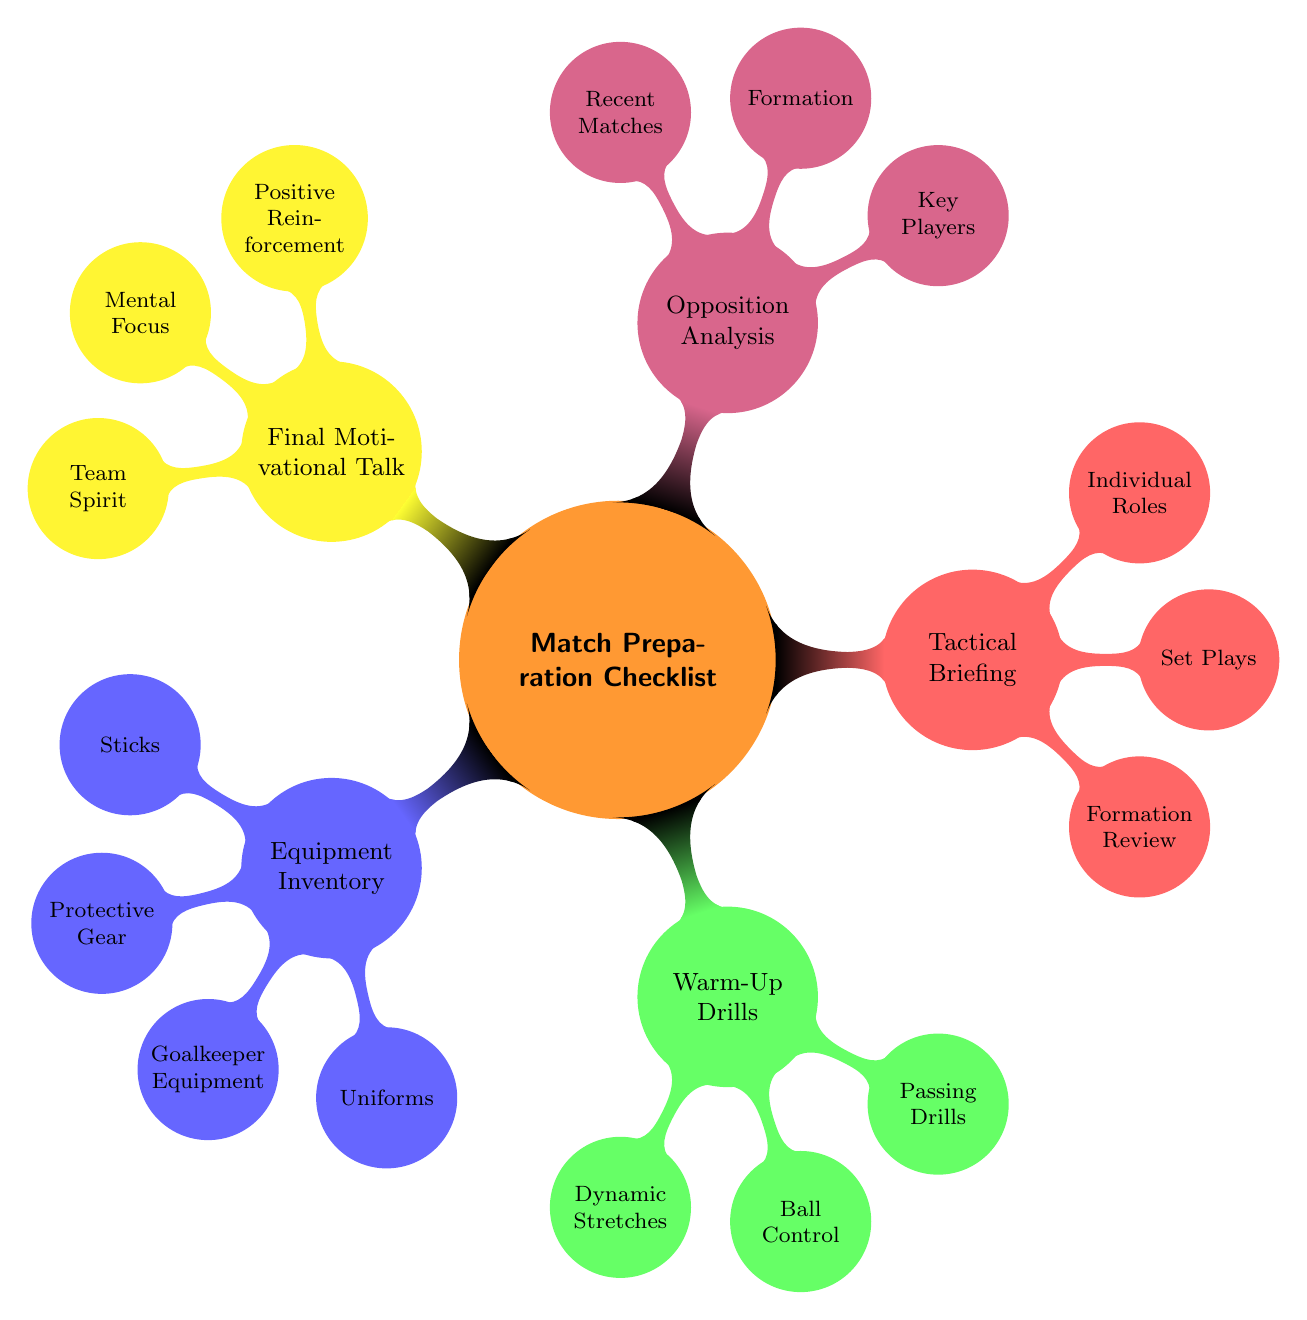What are the main categories in the match preparation checklist? The main categories are listed as child nodes under the "Match Preparation Checklist" node. They include Equipment Inventory, Warm-Up Drills, Tactical Briefing, Opposition Analysis, and Final Motivational Talk.
Answer: Equipment Inventory, Warm-Up Drills, Tactical Briefing, Opposition Analysis, Final Motivational Talk How many items are listed under Tactical Briefing? To find the number of items, we count the child nodes under the "Tactical Briefing" node, which includes Formation Review, Set Plays, Individual Roles, and Opposition Weaknesses. There are four items total.
Answer: 4 Which node is connected to "Key Players"? The "Key Players" node is a child of the "Opposition Analysis" node. This can be determined by looking at the hierarchy in the mind map structure.
Answer: Opposition Analysis What is included in the Equipment Inventory category? The Equipment Inventory category contains Sticks, Protective Gear, Goalkeeper Equipment, Uniforms, and First Aid Kit. We identify these by checking the child nodes of the Equipment Inventory node.
Answer: Sticks, Protective Gear, Goalkeeper Equipment, Uniforms, First Aid Kit Which category includes the drills? The category that includes drills is "Warm-Up Drills", which can be identified as the node that contains various types of drills such as Dynamic Stretches, Ball Control, and Passing Drills.
Answer: Warm-Up Drills How many warm-up drills are listed in the diagram? To determine the number of warm-up drills, we can count the child nodes under the "Warm-Up Drills" node. There are four listed: Dynamic Stretches, Ball Control, Passing Drills, and Small-Sided Games.
Answer: 4 What is the relationship of "Formation Review" to the main categories? "Formation Review" is a child node of the "Tactical Briefing" node, showing that it is a component of the Tactical Briefing category. The hierarchical structure indicates this relationship.
Answer: Tactical Briefing Which motivational aspect highlights team collaboration? The aspect that highlights team collaboration is "Team Spirit", found under the "Final Motivational Talk" category. This reflects one of the focal points of the motivational talk.
Answer: Team Spirit 